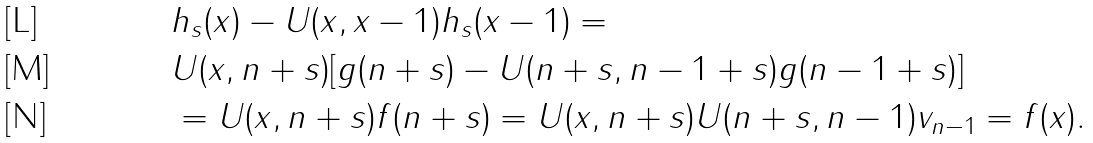<formula> <loc_0><loc_0><loc_500><loc_500>& h _ { s } ( x ) - U ( x , x - 1 ) h _ { s } ( x - 1 ) = \\ & U ( x , n + s ) [ g ( n + s ) - U ( n + s , n - 1 + s ) g ( n - 1 + s ) ] \\ & = U ( x , n + s ) f ( n + s ) = U ( x , n + s ) U ( n + s , n - 1 ) v _ { n - 1 } = f ( x ) .</formula> 